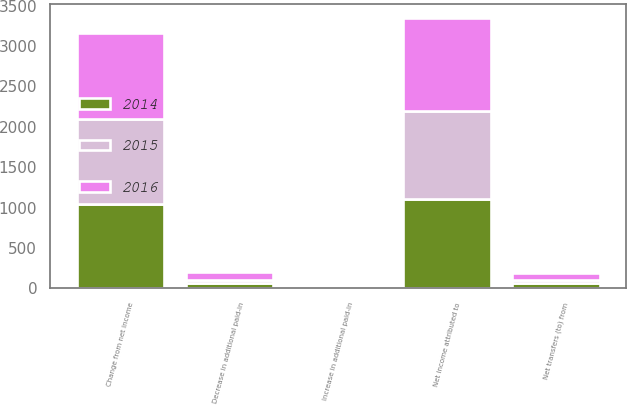Convert chart. <chart><loc_0><loc_0><loc_500><loc_500><stacked_bar_chart><ecel><fcel>Net income attributed to<fcel>Increase in additional paid-in<fcel>Decrease in additional paid-in<fcel>Net transfers (to) from<fcel>Change from net income<nl><fcel>2016<fcel>1148.6<fcel>2<fcel>89.7<fcel>87.7<fcel>1060.9<nl><fcel>2015<fcel>1093.9<fcel>1.7<fcel>40.5<fcel>38.8<fcel>1055.1<nl><fcel>2014<fcel>1104<fcel>6.3<fcel>70.8<fcel>64.5<fcel>1039.5<nl></chart> 